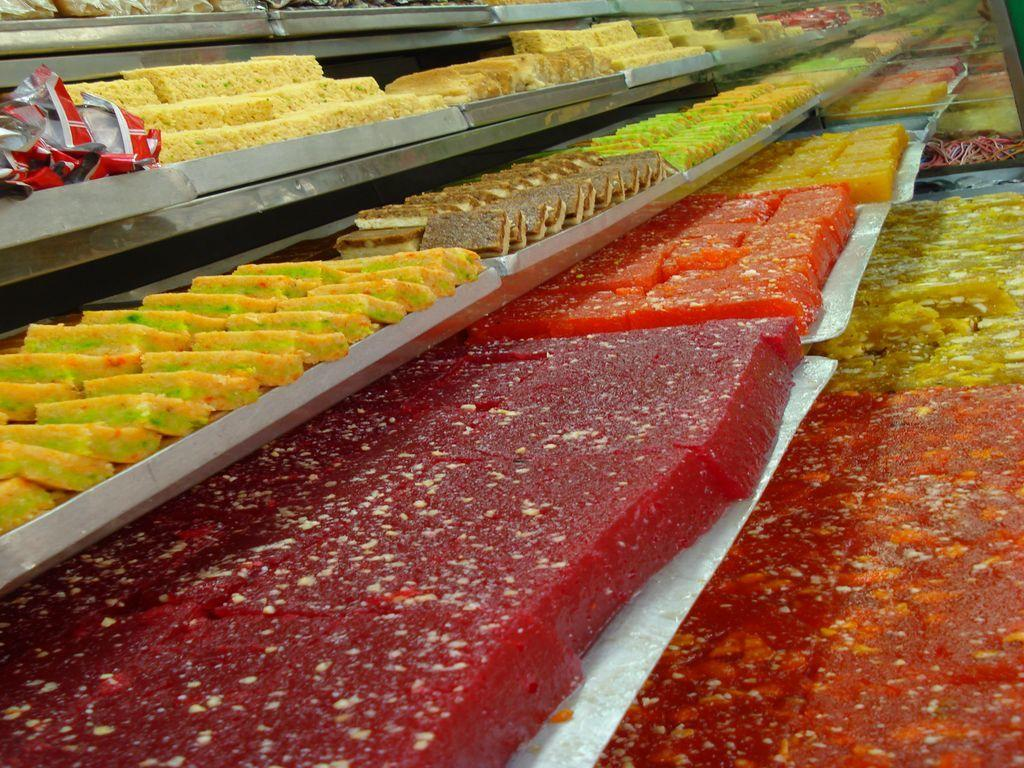What type of items are featured in the image? The image contains many different sweets. How are the sweets organized in the image? The sweets are arranged in a rack. Is there any additional covering or protection visible in the image? Yes, there is a paper cover on the left side of the image. Can you see any ducks swimming in the image? No, there are no ducks present in the image. What type of star can be seen in the image? There is no star visible in the image; it features sweets arranged in a rack with a paper cover. 